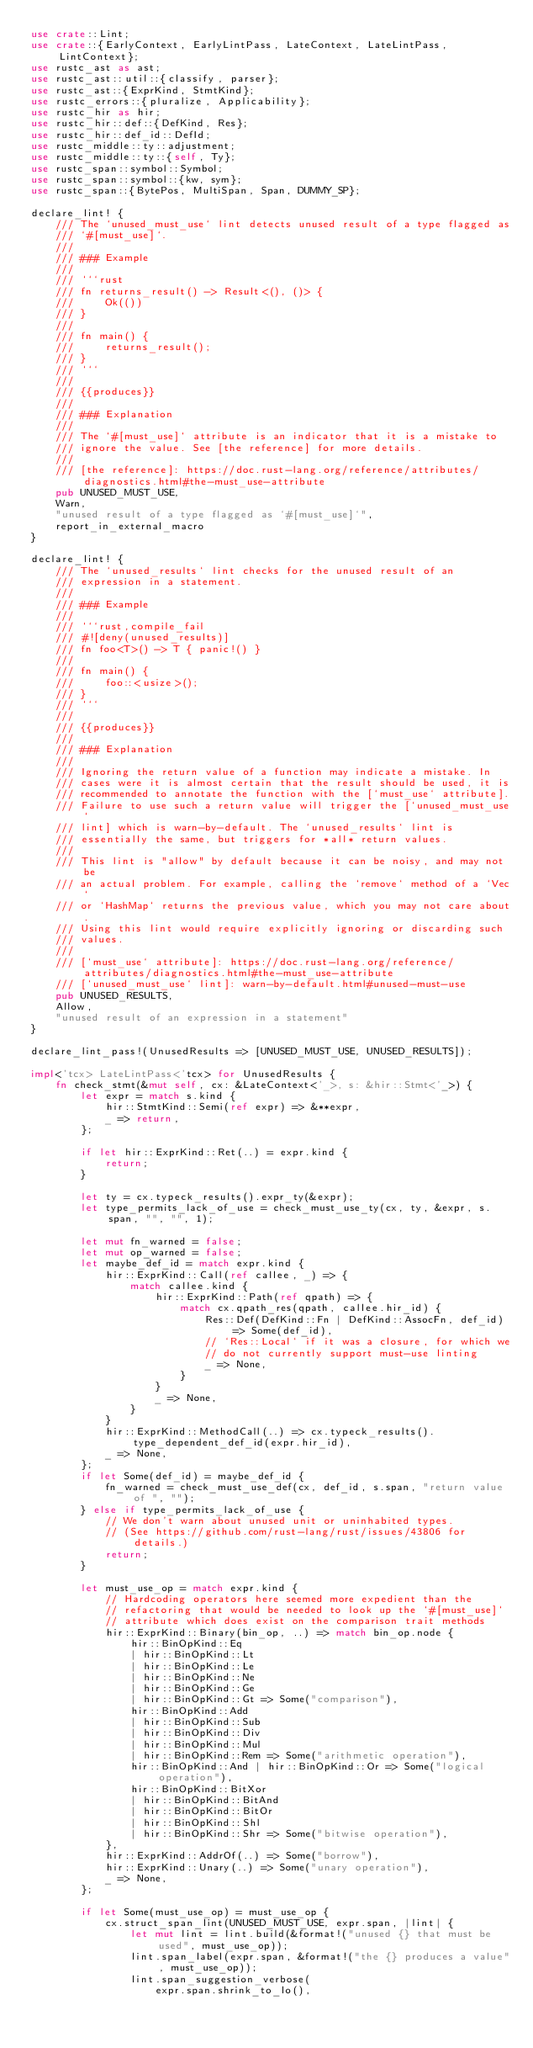Convert code to text. <code><loc_0><loc_0><loc_500><loc_500><_Rust_>use crate::Lint;
use crate::{EarlyContext, EarlyLintPass, LateContext, LateLintPass, LintContext};
use rustc_ast as ast;
use rustc_ast::util::{classify, parser};
use rustc_ast::{ExprKind, StmtKind};
use rustc_errors::{pluralize, Applicability};
use rustc_hir as hir;
use rustc_hir::def::{DefKind, Res};
use rustc_hir::def_id::DefId;
use rustc_middle::ty::adjustment;
use rustc_middle::ty::{self, Ty};
use rustc_span::symbol::Symbol;
use rustc_span::symbol::{kw, sym};
use rustc_span::{BytePos, MultiSpan, Span, DUMMY_SP};

declare_lint! {
    /// The `unused_must_use` lint detects unused result of a type flagged as
    /// `#[must_use]`.
    ///
    /// ### Example
    ///
    /// ```rust
    /// fn returns_result() -> Result<(), ()> {
    ///     Ok(())
    /// }
    ///
    /// fn main() {
    ///     returns_result();
    /// }
    /// ```
    ///
    /// {{produces}}
    ///
    /// ### Explanation
    ///
    /// The `#[must_use]` attribute is an indicator that it is a mistake to
    /// ignore the value. See [the reference] for more details.
    ///
    /// [the reference]: https://doc.rust-lang.org/reference/attributes/diagnostics.html#the-must_use-attribute
    pub UNUSED_MUST_USE,
    Warn,
    "unused result of a type flagged as `#[must_use]`",
    report_in_external_macro
}

declare_lint! {
    /// The `unused_results` lint checks for the unused result of an
    /// expression in a statement.
    ///
    /// ### Example
    ///
    /// ```rust,compile_fail
    /// #![deny(unused_results)]
    /// fn foo<T>() -> T { panic!() }
    ///
    /// fn main() {
    ///     foo::<usize>();
    /// }
    /// ```
    ///
    /// {{produces}}
    ///
    /// ### Explanation
    ///
    /// Ignoring the return value of a function may indicate a mistake. In
    /// cases were it is almost certain that the result should be used, it is
    /// recommended to annotate the function with the [`must_use` attribute].
    /// Failure to use such a return value will trigger the [`unused_must_use`
    /// lint] which is warn-by-default. The `unused_results` lint is
    /// essentially the same, but triggers for *all* return values.
    ///
    /// This lint is "allow" by default because it can be noisy, and may not be
    /// an actual problem. For example, calling the `remove` method of a `Vec`
    /// or `HashMap` returns the previous value, which you may not care about.
    /// Using this lint would require explicitly ignoring or discarding such
    /// values.
    ///
    /// [`must_use` attribute]: https://doc.rust-lang.org/reference/attributes/diagnostics.html#the-must_use-attribute
    /// [`unused_must_use` lint]: warn-by-default.html#unused-must-use
    pub UNUSED_RESULTS,
    Allow,
    "unused result of an expression in a statement"
}

declare_lint_pass!(UnusedResults => [UNUSED_MUST_USE, UNUSED_RESULTS]);

impl<'tcx> LateLintPass<'tcx> for UnusedResults {
    fn check_stmt(&mut self, cx: &LateContext<'_>, s: &hir::Stmt<'_>) {
        let expr = match s.kind {
            hir::StmtKind::Semi(ref expr) => &**expr,
            _ => return,
        };

        if let hir::ExprKind::Ret(..) = expr.kind {
            return;
        }

        let ty = cx.typeck_results().expr_ty(&expr);
        let type_permits_lack_of_use = check_must_use_ty(cx, ty, &expr, s.span, "", "", 1);

        let mut fn_warned = false;
        let mut op_warned = false;
        let maybe_def_id = match expr.kind {
            hir::ExprKind::Call(ref callee, _) => {
                match callee.kind {
                    hir::ExprKind::Path(ref qpath) => {
                        match cx.qpath_res(qpath, callee.hir_id) {
                            Res::Def(DefKind::Fn | DefKind::AssocFn, def_id) => Some(def_id),
                            // `Res::Local` if it was a closure, for which we
                            // do not currently support must-use linting
                            _ => None,
                        }
                    }
                    _ => None,
                }
            }
            hir::ExprKind::MethodCall(..) => cx.typeck_results().type_dependent_def_id(expr.hir_id),
            _ => None,
        };
        if let Some(def_id) = maybe_def_id {
            fn_warned = check_must_use_def(cx, def_id, s.span, "return value of ", "");
        } else if type_permits_lack_of_use {
            // We don't warn about unused unit or uninhabited types.
            // (See https://github.com/rust-lang/rust/issues/43806 for details.)
            return;
        }

        let must_use_op = match expr.kind {
            // Hardcoding operators here seemed more expedient than the
            // refactoring that would be needed to look up the `#[must_use]`
            // attribute which does exist on the comparison trait methods
            hir::ExprKind::Binary(bin_op, ..) => match bin_op.node {
                hir::BinOpKind::Eq
                | hir::BinOpKind::Lt
                | hir::BinOpKind::Le
                | hir::BinOpKind::Ne
                | hir::BinOpKind::Ge
                | hir::BinOpKind::Gt => Some("comparison"),
                hir::BinOpKind::Add
                | hir::BinOpKind::Sub
                | hir::BinOpKind::Div
                | hir::BinOpKind::Mul
                | hir::BinOpKind::Rem => Some("arithmetic operation"),
                hir::BinOpKind::And | hir::BinOpKind::Or => Some("logical operation"),
                hir::BinOpKind::BitXor
                | hir::BinOpKind::BitAnd
                | hir::BinOpKind::BitOr
                | hir::BinOpKind::Shl
                | hir::BinOpKind::Shr => Some("bitwise operation"),
            },
            hir::ExprKind::AddrOf(..) => Some("borrow"),
            hir::ExprKind::Unary(..) => Some("unary operation"),
            _ => None,
        };

        if let Some(must_use_op) = must_use_op {
            cx.struct_span_lint(UNUSED_MUST_USE, expr.span, |lint| {
                let mut lint = lint.build(&format!("unused {} that must be used", must_use_op));
                lint.span_label(expr.span, &format!("the {} produces a value", must_use_op));
                lint.span_suggestion_verbose(
                    expr.span.shrink_to_lo(),</code> 